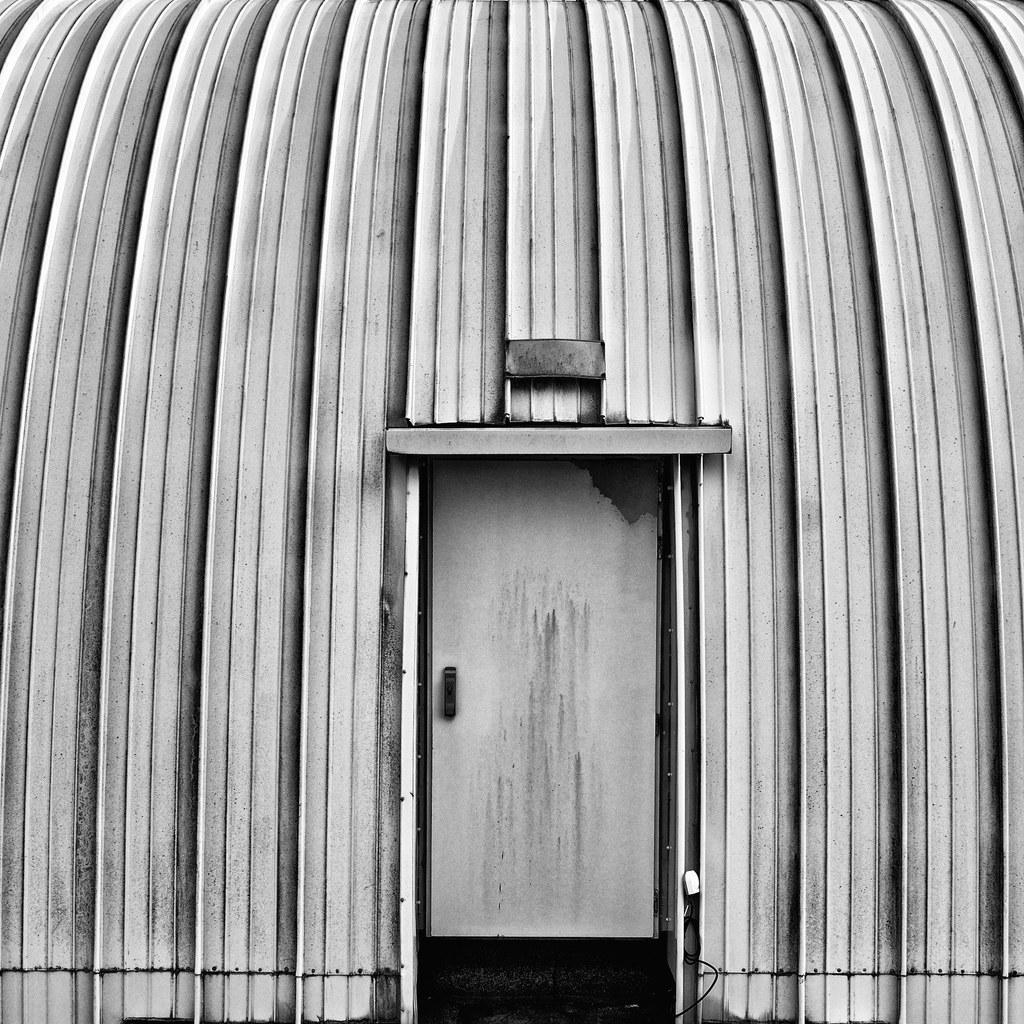How would you summarize this image in a sentence or two? In the picture we can see a part of the house wall with a door and handle to it and on the wall we can see the lines. 